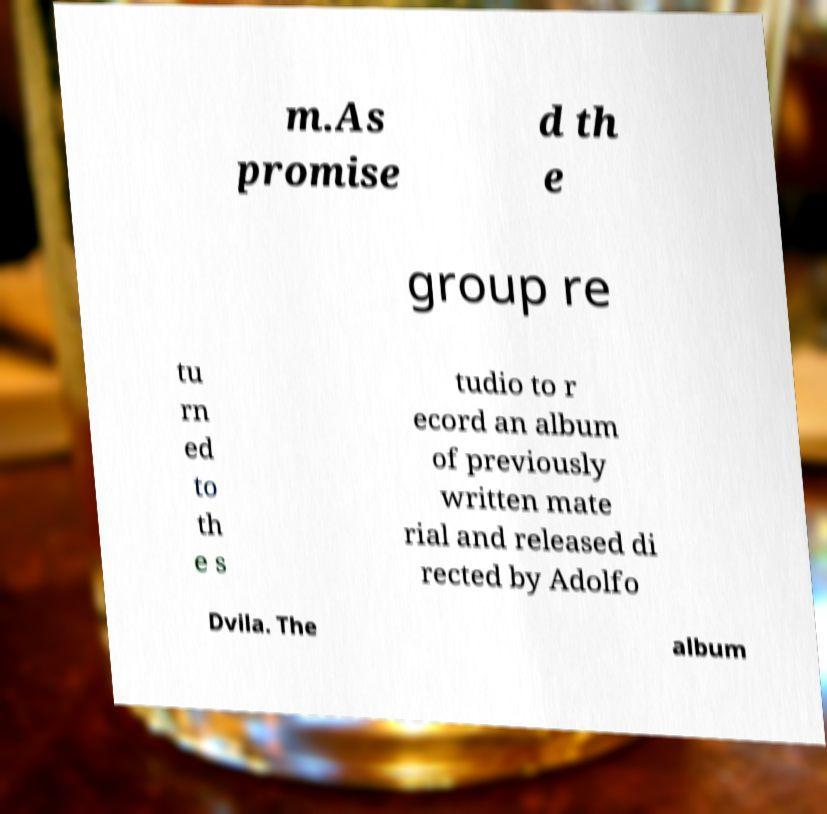Can you read and provide the text displayed in the image?This photo seems to have some interesting text. Can you extract and type it out for me? m.As promise d th e group re tu rn ed to th e s tudio to r ecord an album of previously written mate rial and released di rected by Adolfo Dvila. The album 